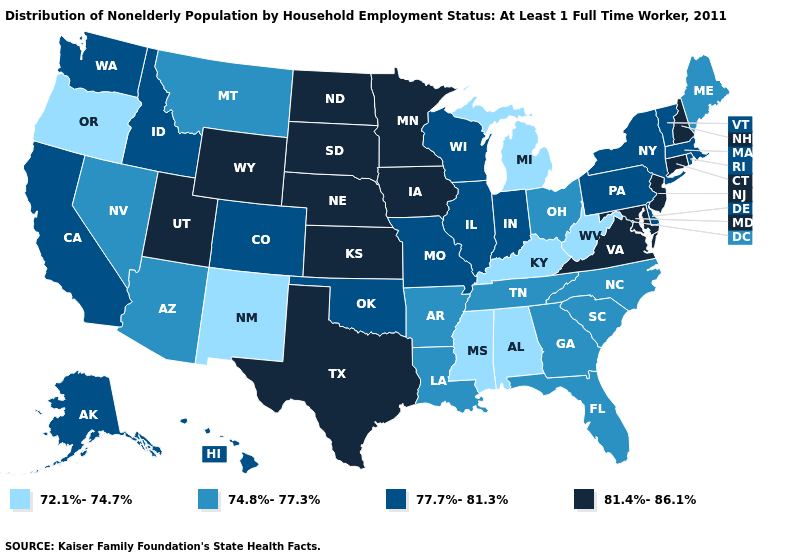Name the states that have a value in the range 77.7%-81.3%?
Quick response, please. Alaska, California, Colorado, Delaware, Hawaii, Idaho, Illinois, Indiana, Massachusetts, Missouri, New York, Oklahoma, Pennsylvania, Rhode Island, Vermont, Washington, Wisconsin. Which states have the highest value in the USA?
Quick response, please. Connecticut, Iowa, Kansas, Maryland, Minnesota, Nebraska, New Hampshire, New Jersey, North Dakota, South Dakota, Texas, Utah, Virginia, Wyoming. Does Florida have the highest value in the USA?
Concise answer only. No. Is the legend a continuous bar?
Answer briefly. No. What is the value of Arkansas?
Be succinct. 74.8%-77.3%. Name the states that have a value in the range 74.8%-77.3%?
Give a very brief answer. Arizona, Arkansas, Florida, Georgia, Louisiana, Maine, Montana, Nevada, North Carolina, Ohio, South Carolina, Tennessee. What is the value of Alaska?
Write a very short answer. 77.7%-81.3%. Name the states that have a value in the range 77.7%-81.3%?
Keep it brief. Alaska, California, Colorado, Delaware, Hawaii, Idaho, Illinois, Indiana, Massachusetts, Missouri, New York, Oklahoma, Pennsylvania, Rhode Island, Vermont, Washington, Wisconsin. Which states have the lowest value in the West?
Concise answer only. New Mexico, Oregon. What is the value of Oklahoma?
Be succinct. 77.7%-81.3%. Name the states that have a value in the range 77.7%-81.3%?
Write a very short answer. Alaska, California, Colorado, Delaware, Hawaii, Idaho, Illinois, Indiana, Massachusetts, Missouri, New York, Oklahoma, Pennsylvania, Rhode Island, Vermont, Washington, Wisconsin. Name the states that have a value in the range 72.1%-74.7%?
Write a very short answer. Alabama, Kentucky, Michigan, Mississippi, New Mexico, Oregon, West Virginia. What is the value of Mississippi?
Write a very short answer. 72.1%-74.7%. Does New York have the lowest value in the Northeast?
Write a very short answer. No. What is the value of North Carolina?
Quick response, please. 74.8%-77.3%. 